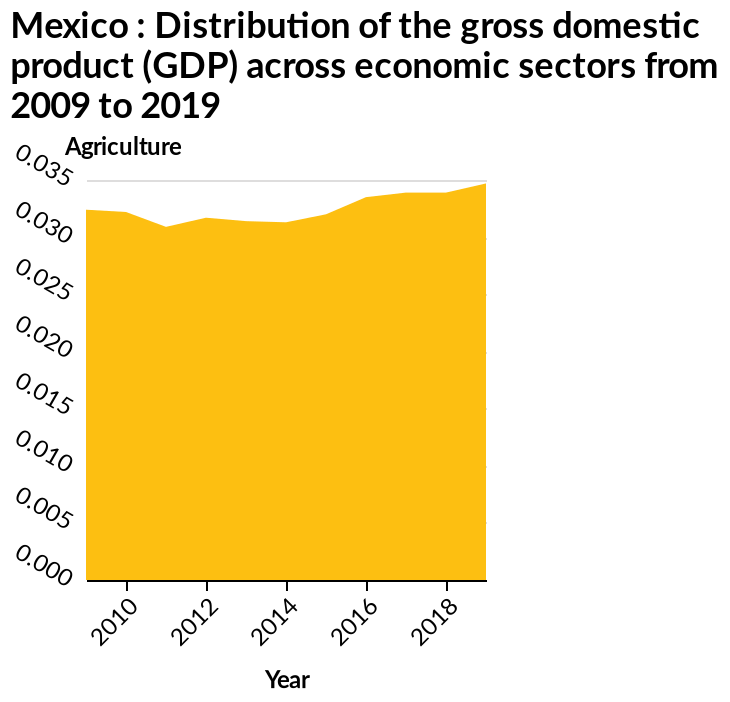<image>
What is the trend in the distribution of the gross domestic product? The trend is a consistent increase in the distribution from 2009 to 2019. 